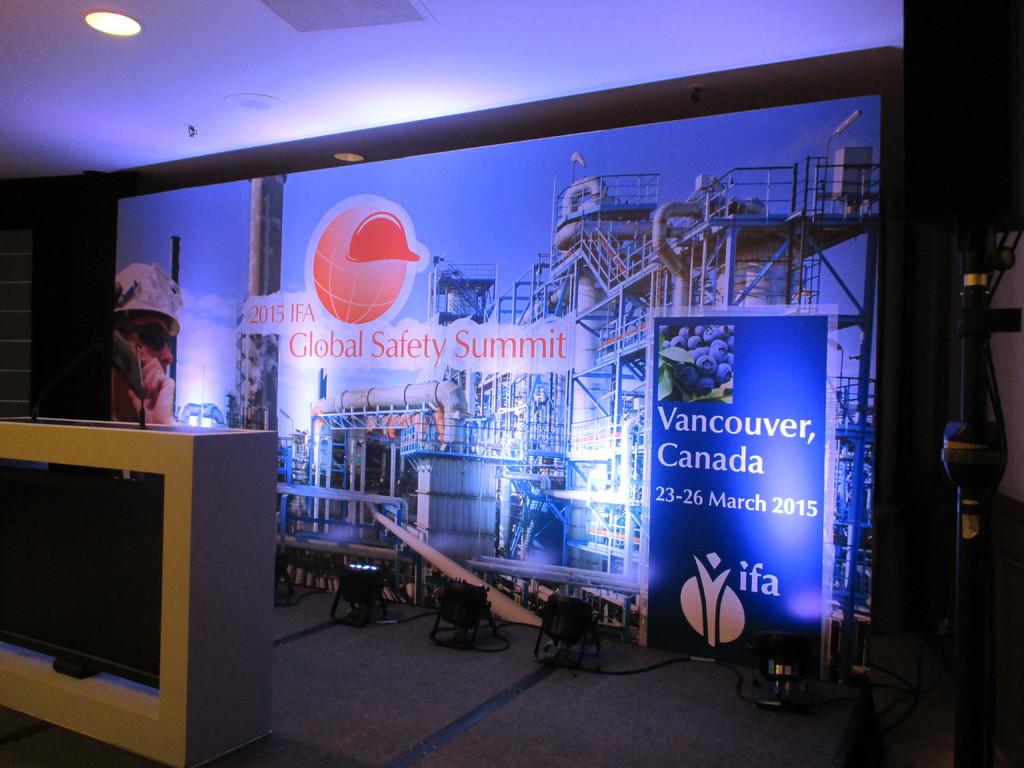Where in canada is showing on poster?
Your answer should be very brief. Vancouver. 